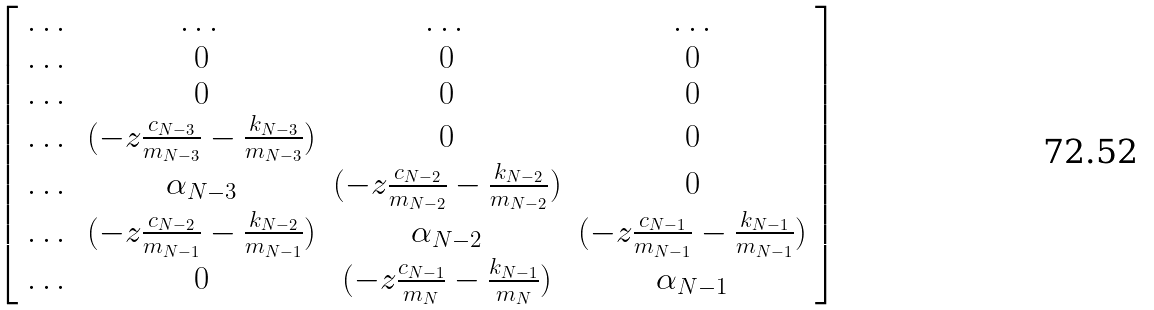<formula> <loc_0><loc_0><loc_500><loc_500>\left [ \begin{array} { c c c c } \dots & \dots & \dots & \dots \\ \dots & 0 & 0 & 0 \\ \dots & 0 & 0 & 0 \\ \dots & ( - z \frac { c _ { N - 3 } } { m _ { N - 3 } } - \frac { k _ { N - 3 } } { m _ { N - 3 } } ) & 0 & 0 \\ \dots & \alpha _ { N - 3 } & ( - z \frac { c _ { N - 2 } } { m _ { N - 2 } } - \frac { k _ { N - 2 } } { m _ { N - 2 } } ) & 0 \\ \dots & ( - z \frac { c _ { N - 2 } } { m _ { N - 1 } } - \frac { k _ { N - 2 } } { m _ { N - 1 } } ) & \alpha _ { N - 2 } & ( - z \frac { c _ { N - 1 } } { m _ { N - 1 } } - \frac { k _ { N - 1 } } { m _ { N - 1 } } ) \\ \dots & 0 & ( - z \frac { c _ { N - 1 } } { m _ { N } } - \frac { k _ { N - 1 } } { m _ { N } } ) & \alpha _ { N - 1 } \\ \end{array} \right ]</formula> 